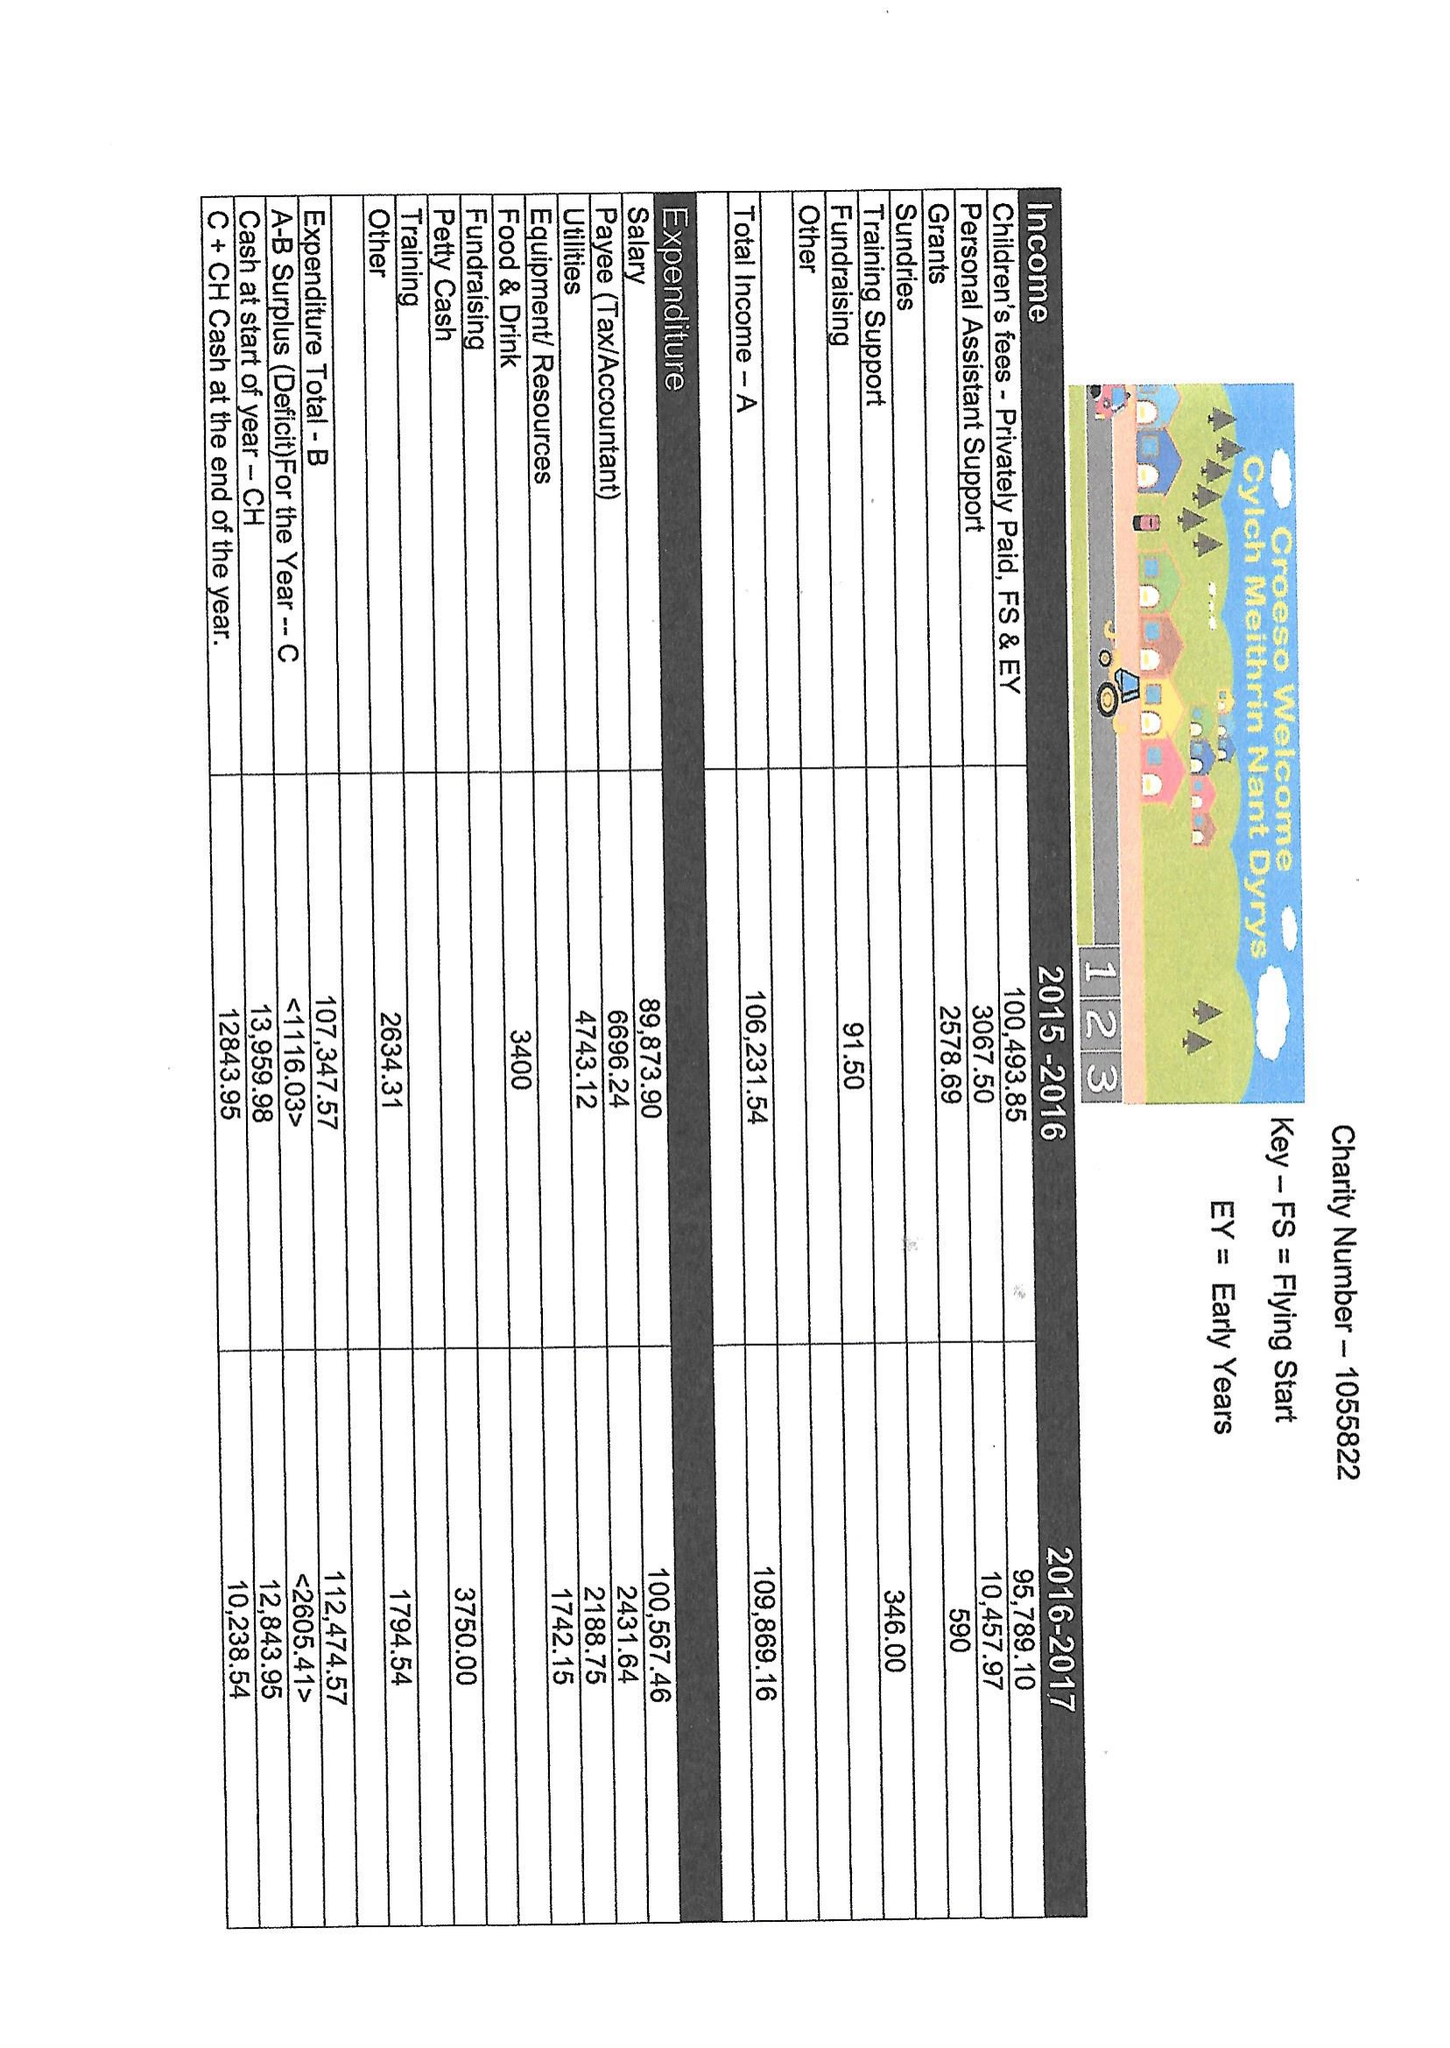What is the value for the charity_number?
Answer the question using a single word or phrase. 1055822 